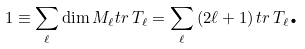<formula> <loc_0><loc_0><loc_500><loc_500>1 \equiv \sum _ { \ell } \dim M _ { \ell } t r \, T _ { \ell } = \sum _ { \ell } \left ( 2 \ell + 1 \right ) t r \, T _ { \ell } \text {.}</formula> 